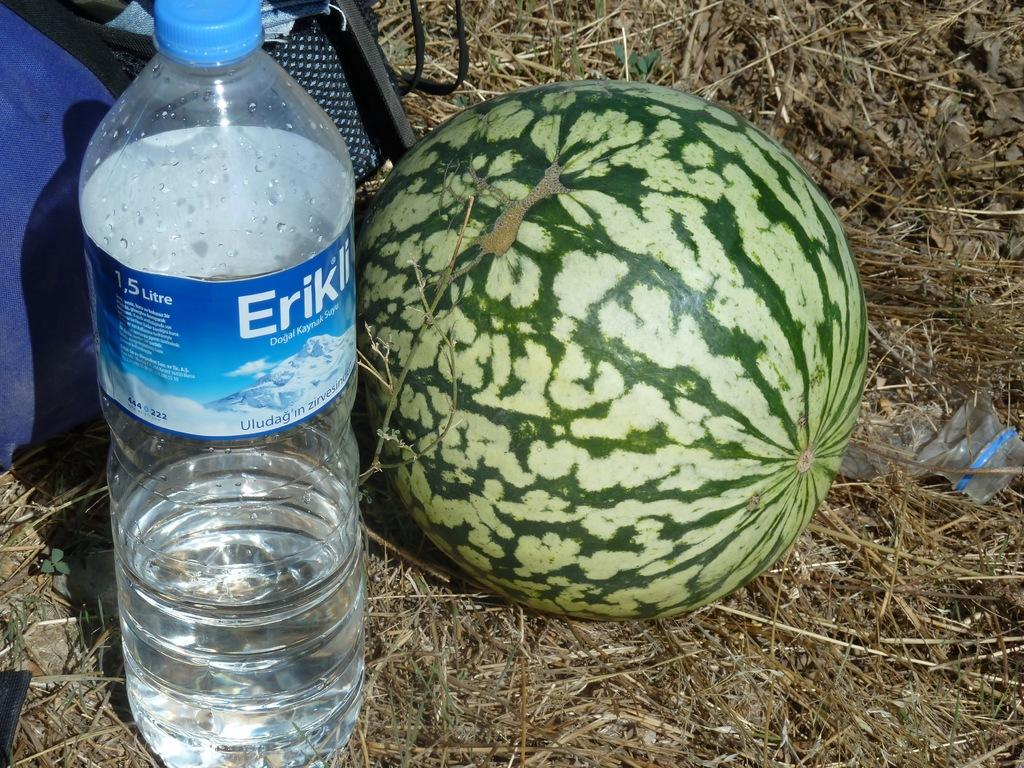What type of fruit is in the image? There is a watermelon in the image. What type of container is visible in the image? There is a water bottle in the image. What type of personal item is in the image? There is a bag in the image. Where are the objects located in the image? The objects are on the grass. What type of bedroom furniture is visible in the image? There is no bedroom furniture present in the image; it features a watermelon, water bottle, and bag on the grass. What type of system is being used to organize the objects in the image? There is no system being used to organize the objects in the image; they are simply placed on the grass. 